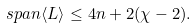<formula> <loc_0><loc_0><loc_500><loc_500>s p a n \langle L \rangle \leq 4 n + 2 ( \chi - 2 ) .</formula> 